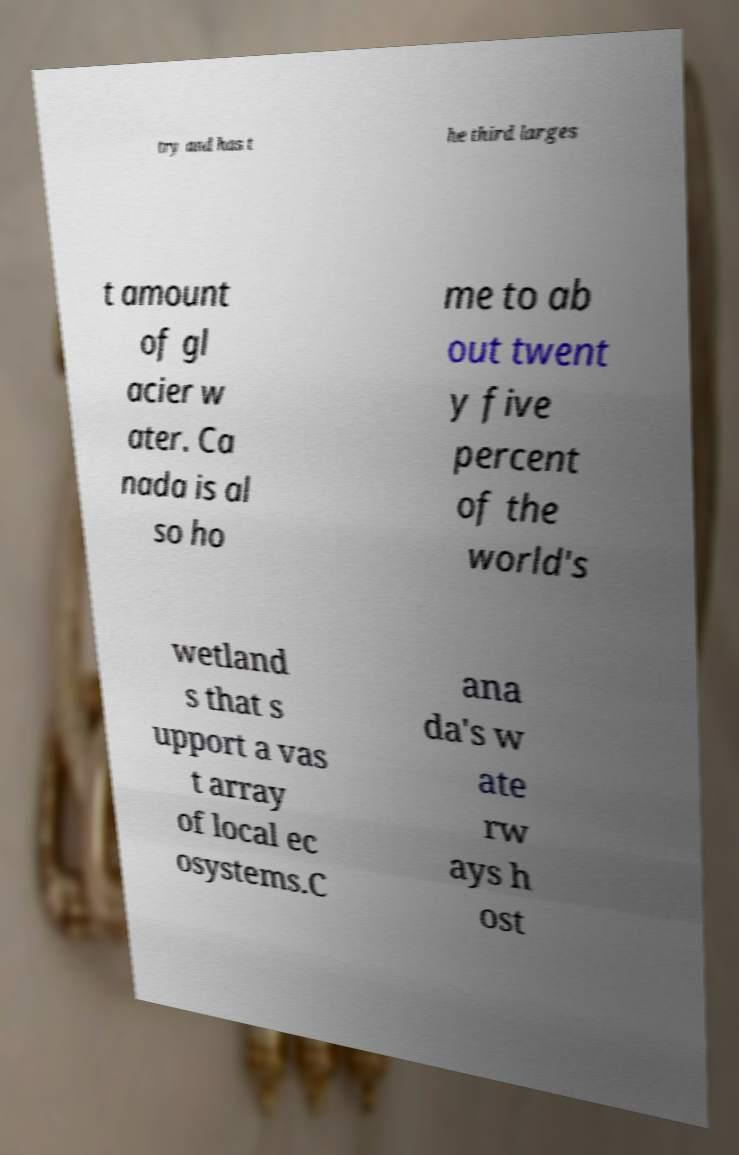Can you read and provide the text displayed in the image?This photo seems to have some interesting text. Can you extract and type it out for me? try and has t he third larges t amount of gl acier w ater. Ca nada is al so ho me to ab out twent y five percent of the world's wetland s that s upport a vas t array of local ec osystems.C ana da's w ate rw ays h ost 